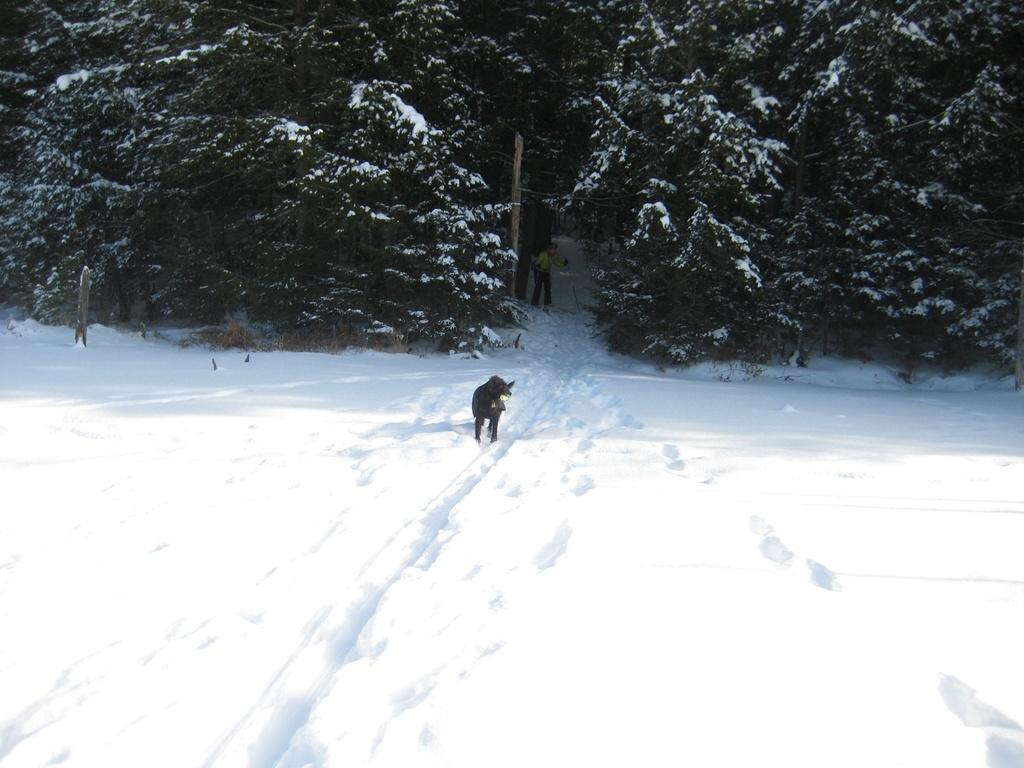What type of vegetation can be seen towards the top of the image? There are trees visible towards the top of the image. What type of weather condition is depicted towards the bottom of the image? There is snow visible towards the bottom of the image. What type of living creature is present in the image? There is an animal in the image. What is the man in the image doing? The man is standing in the image and holding an object. Can you hear the thunder in the image? There is no mention of thunder in the image, so it cannot be heard. Is the man sneezing in the image? There is no indication of the man sneezing in the image. 